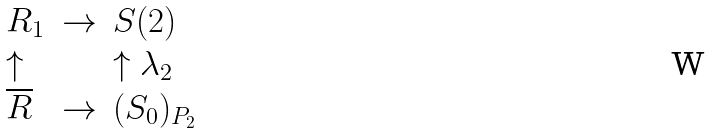Convert formula to latex. <formula><loc_0><loc_0><loc_500><loc_500>\begin{array} { l l l } R _ { 1 } & \rightarrow & S ( 2 ) \\ \uparrow & & \uparrow \lambda _ { 2 } \\ \overline { R } & \rightarrow & ( S _ { 0 } ) _ { P _ { 2 } } \end{array}</formula> 